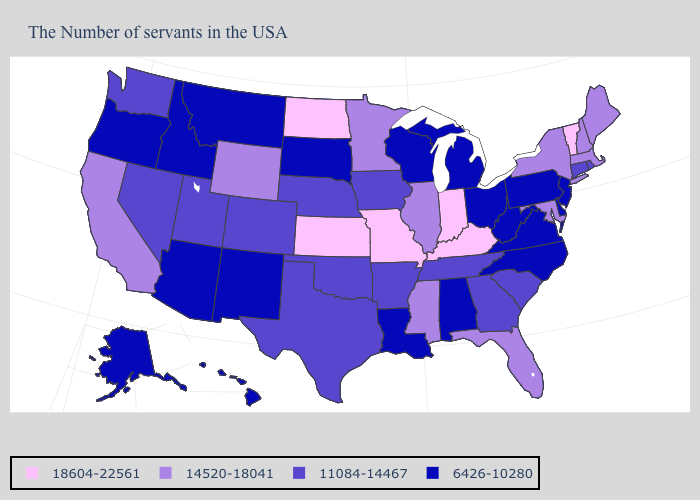Does Connecticut have a higher value than Alaska?
Give a very brief answer. Yes. Does the first symbol in the legend represent the smallest category?
Give a very brief answer. No. What is the value of West Virginia?
Quick response, please. 6426-10280. What is the value of Connecticut?
Answer briefly. 11084-14467. Does Nebraska have a higher value than South Carolina?
Keep it brief. No. How many symbols are there in the legend?
Give a very brief answer. 4. Which states have the highest value in the USA?
Write a very short answer. Vermont, Kentucky, Indiana, Missouri, Kansas, North Dakota. Which states have the lowest value in the USA?
Short answer required. New Jersey, Delaware, Pennsylvania, Virginia, North Carolina, West Virginia, Ohio, Michigan, Alabama, Wisconsin, Louisiana, South Dakota, New Mexico, Montana, Arizona, Idaho, Oregon, Alaska, Hawaii. Which states have the lowest value in the USA?
Give a very brief answer. New Jersey, Delaware, Pennsylvania, Virginia, North Carolina, West Virginia, Ohio, Michigan, Alabama, Wisconsin, Louisiana, South Dakota, New Mexico, Montana, Arizona, Idaho, Oregon, Alaska, Hawaii. Which states have the lowest value in the USA?
Short answer required. New Jersey, Delaware, Pennsylvania, Virginia, North Carolina, West Virginia, Ohio, Michigan, Alabama, Wisconsin, Louisiana, South Dakota, New Mexico, Montana, Arizona, Idaho, Oregon, Alaska, Hawaii. How many symbols are there in the legend?
Keep it brief. 4. Does California have the lowest value in the West?
Short answer required. No. Name the states that have a value in the range 18604-22561?
Write a very short answer. Vermont, Kentucky, Indiana, Missouri, Kansas, North Dakota. 